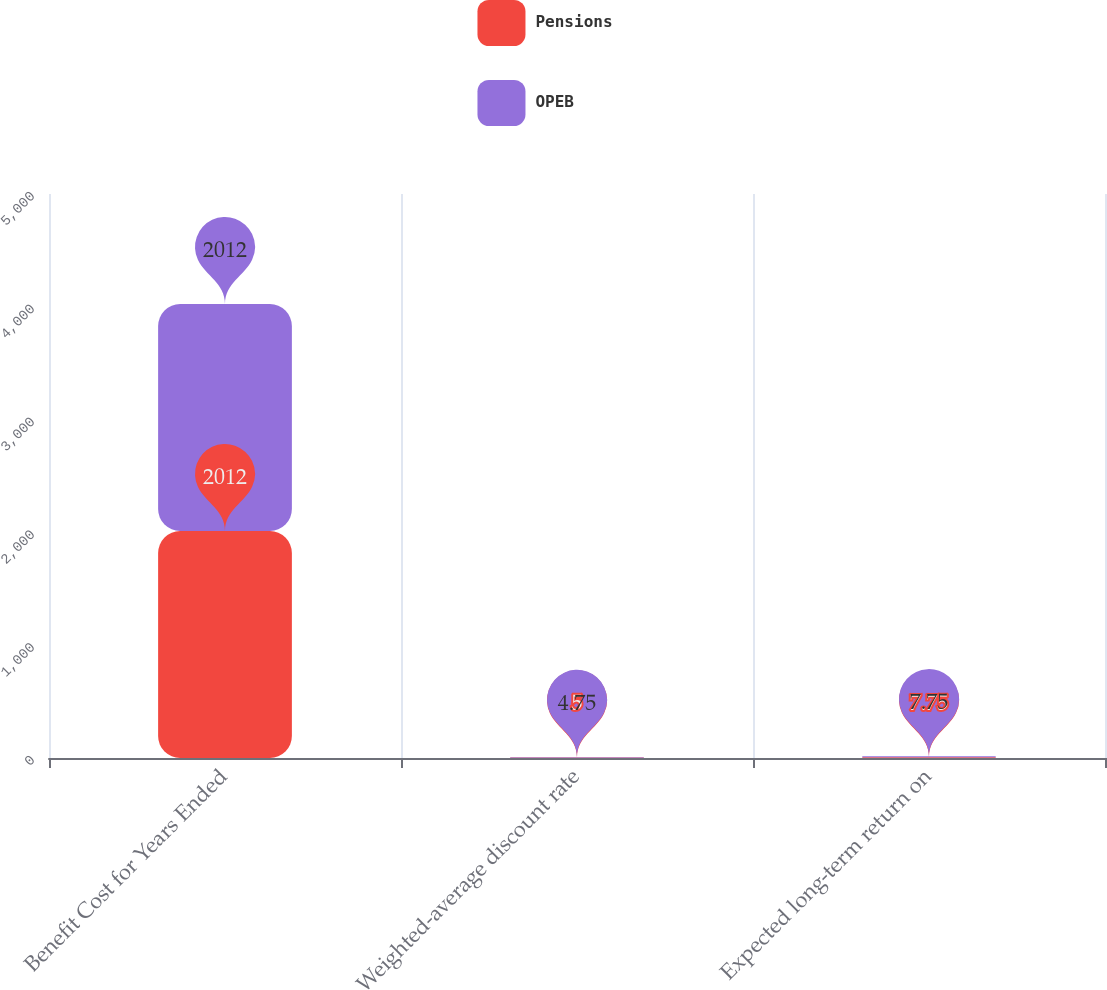Convert chart. <chart><loc_0><loc_0><loc_500><loc_500><stacked_bar_chart><ecel><fcel>Benefit Cost for Years Ended<fcel>Weighted-average discount rate<fcel>Expected long-term return on<nl><fcel>Pensions<fcel>2012<fcel>5<fcel>7.75<nl><fcel>OPEB<fcel>2012<fcel>4.75<fcel>7.75<nl></chart> 